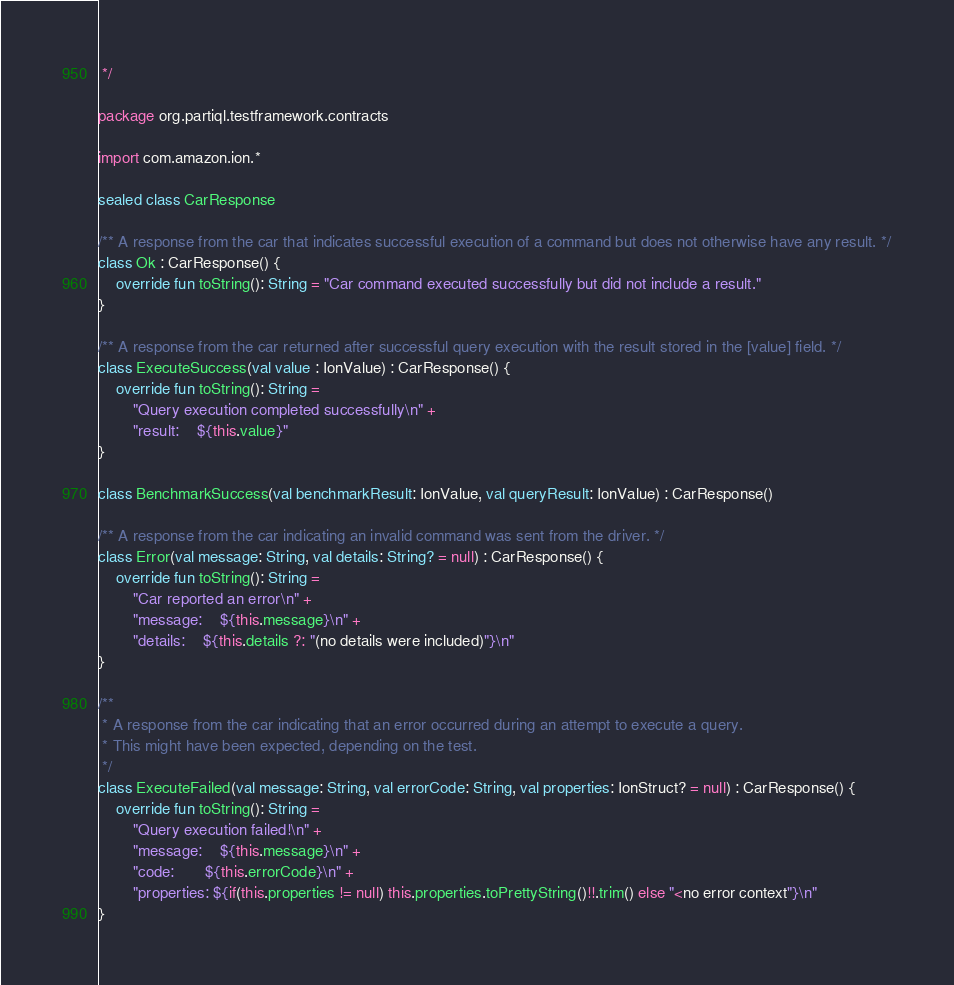Convert code to text. <code><loc_0><loc_0><loc_500><loc_500><_Kotlin_> */

package org.partiql.testframework.contracts

import com.amazon.ion.*

sealed class CarResponse

/** A response from the car that indicates successful execution of a command but does not otherwise have any result. */
class Ok : CarResponse() {
    override fun toString(): String = "Car command executed successfully but did not include a result."
}

/** A response from the car returned after successful query execution with the result stored in the [value] field. */
class ExecuteSuccess(val value : IonValue) : CarResponse() {
    override fun toString(): String =
        "Query execution completed successfully\n" +
        "result:    ${this.value}"
}

class BenchmarkSuccess(val benchmarkResult: IonValue, val queryResult: IonValue) : CarResponse()

/** A response from the car indicating an invalid command was sent from the driver. */
class Error(val message: String, val details: String? = null) : CarResponse() {
    override fun toString(): String =
        "Car reported an error\n" +
        "message:    ${this.message}\n" +
        "details:    ${this.details ?: "(no details were included)"}\n"
}

/**
 * A response from the car indicating that an error occurred during an attempt to execute a query.
 * This might have been expected, depending on the test.
 */
class ExecuteFailed(val message: String, val errorCode: String, val properties: IonStruct? = null) : CarResponse() {
    override fun toString(): String =
        "Query execution failed!\n" +
        "message:    ${this.message}\n" +
        "code:       ${this.errorCode}\n" +
        "properties: ${if(this.properties != null) this.properties.toPrettyString()!!.trim() else "<no error context"}\n"
}

</code> 